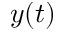<formula> <loc_0><loc_0><loc_500><loc_500>y ( t )</formula> 